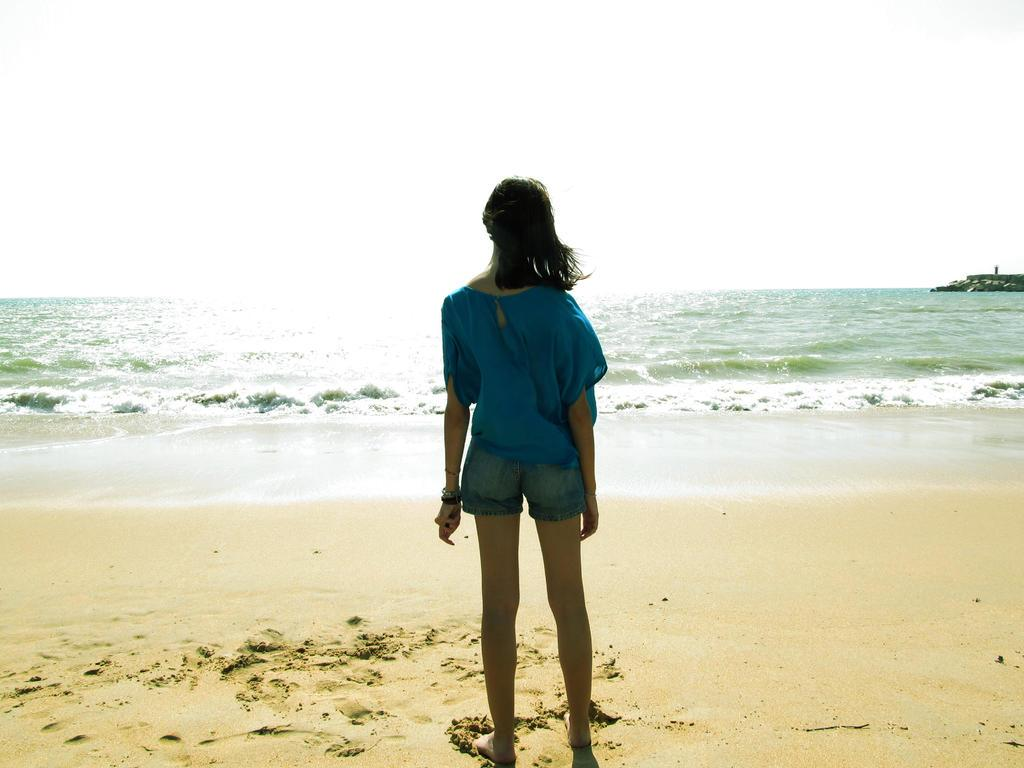Who is present in the image? There is a woman in the image. What is the woman wearing? The woman is wearing a dress. Can you describe the woman's hairstyle? The woman's hair is short. What is the woman doing in the image? The woman is standing. What can be seen in the background of the image? There are waves, water, sand, and the sky visible in the background of the image. What type of crib is visible in the image? There is no crib present in the image. What form does the water take in the image? The water is visible in the form of waves in the background of the image. 